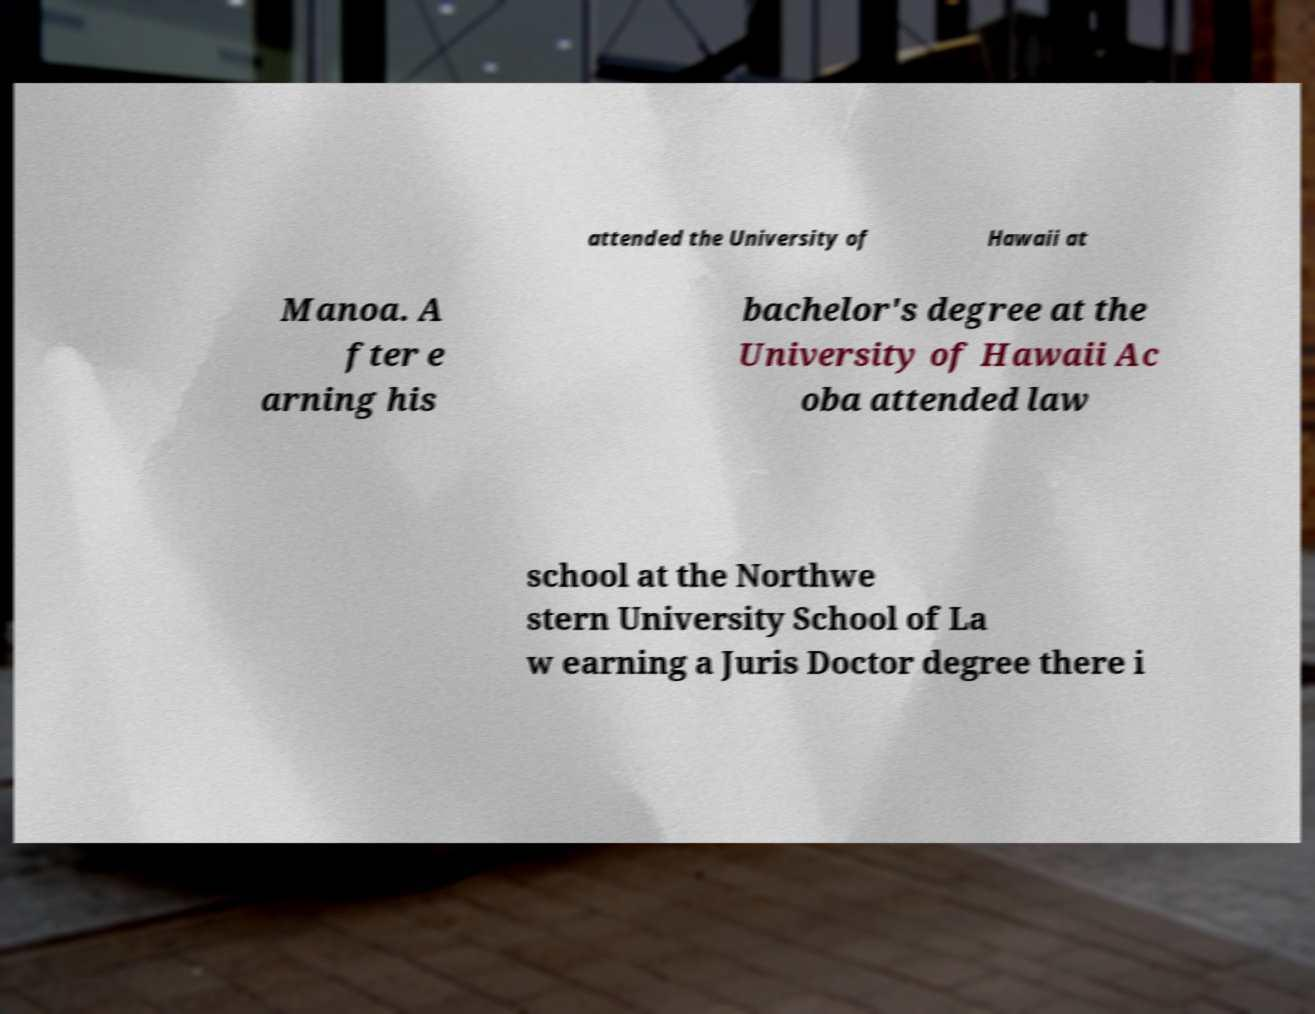There's text embedded in this image that I need extracted. Can you transcribe it verbatim? attended the University of Hawaii at Manoa. A fter e arning his bachelor's degree at the University of Hawaii Ac oba attended law school at the Northwe stern University School of La w earning a Juris Doctor degree there i 